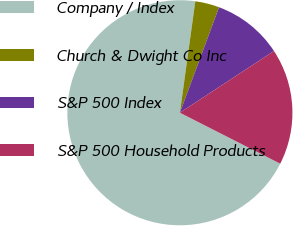Convert chart. <chart><loc_0><loc_0><loc_500><loc_500><pie_chart><fcel>Company / Index<fcel>Church & Dwight Co Inc<fcel>S&P 500 Index<fcel>S&P 500 Household Products<nl><fcel>69.71%<fcel>3.47%<fcel>10.1%<fcel>16.72%<nl></chart> 